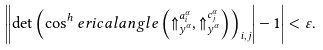<formula> <loc_0><loc_0><loc_500><loc_500>\left | \left | \det \left ( \cos ^ { h } e r i c a l a n g l e \left ( \Uparrow _ { y ^ { \alpha } } ^ { a _ { i } ^ { \alpha } } , \Uparrow _ { y ^ { \alpha } } ^ { c _ { j } ^ { \alpha } } \right ) \right ) _ { i , j } \right | - 1 \right | < \varepsilon .</formula> 